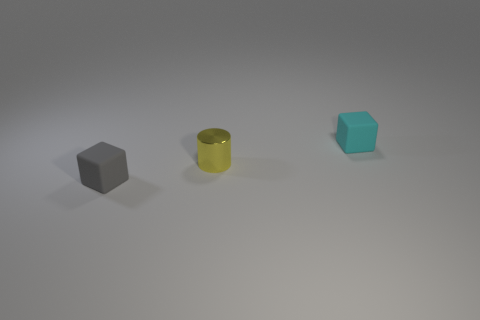Which object stands out the most in this image, and why do you think that is? The yellow cylindrical object stands out due to its height and reflective surface, drawing your attention amidst the matte objects. 